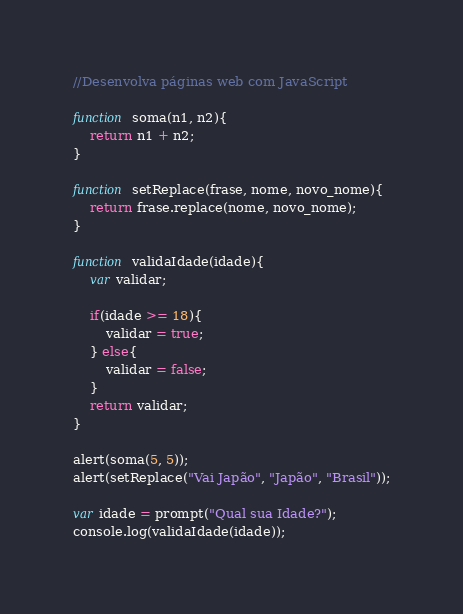<code> <loc_0><loc_0><loc_500><loc_500><_JavaScript_>//Desenvolva páginas web com JavaScript

function soma(n1, n2){
	return n1 + n2;
}

function setReplace(frase, nome, novo_nome){
	return frase.replace(nome, novo_nome);
}

function validaIdade(idade){
	var validar;

	if(idade >= 18){
		validar = true;
	} else{
		validar = false;
	}
	return validar;
}

alert(soma(5, 5));
alert(setReplace("Vai Japão", "Japão", "Brasil"));

var idade = prompt("Qual sua Idade?");
console.log(validaIdade(idade));</code> 